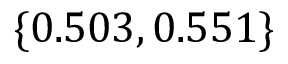<formula> <loc_0><loc_0><loc_500><loc_500>\{ 0 . 5 0 3 , 0 . 5 5 1 \}</formula> 